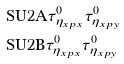Convert formula to latex. <formula><loc_0><loc_0><loc_500><loc_500>& \text {SU2A} \tau ^ { 0 } _ { \eta _ { x p x } } \tau ^ { 0 } _ { \eta _ { x p y } } \\ & \text {SU2B} \tau ^ { 0 } _ { \eta _ { x p x } } \tau ^ { 0 } _ { \eta _ { x p y } }</formula> 